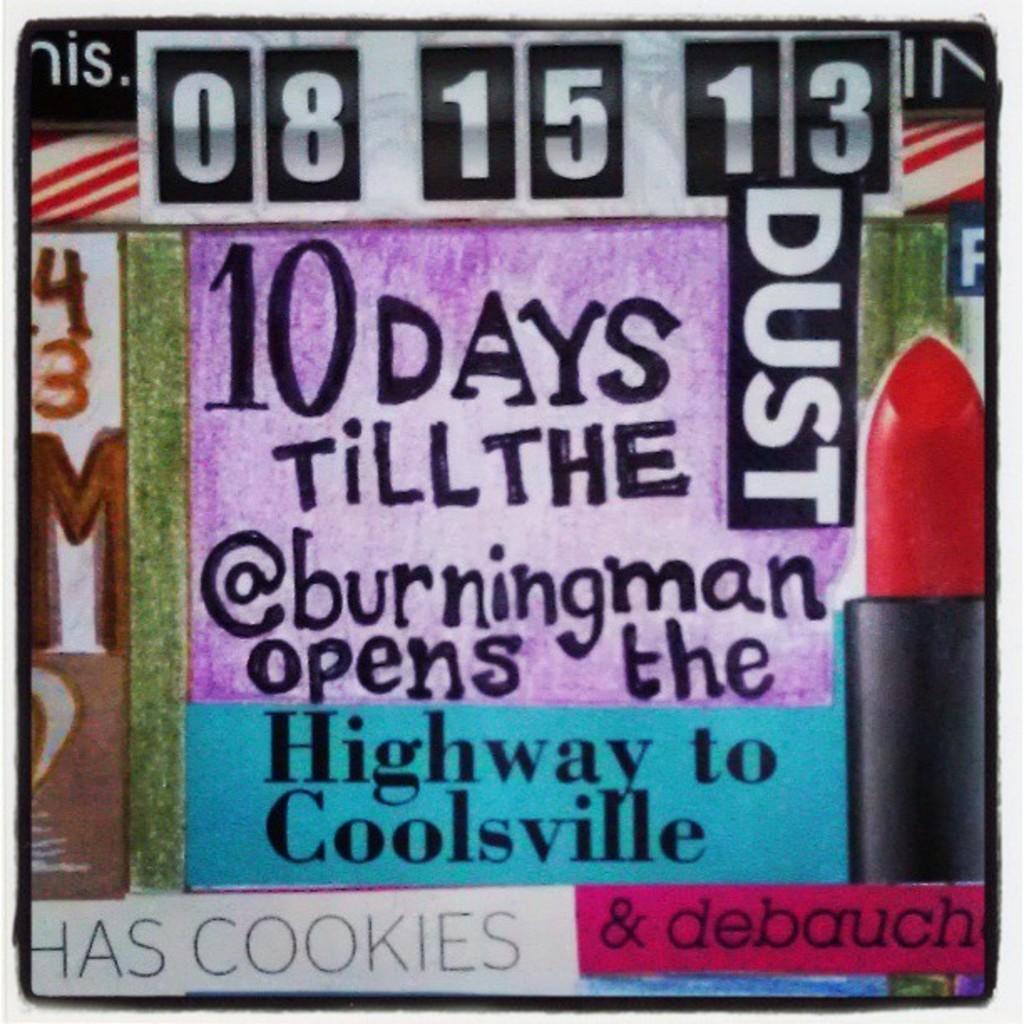Can you describe this image briefly? In this image there is a poster with some text. 